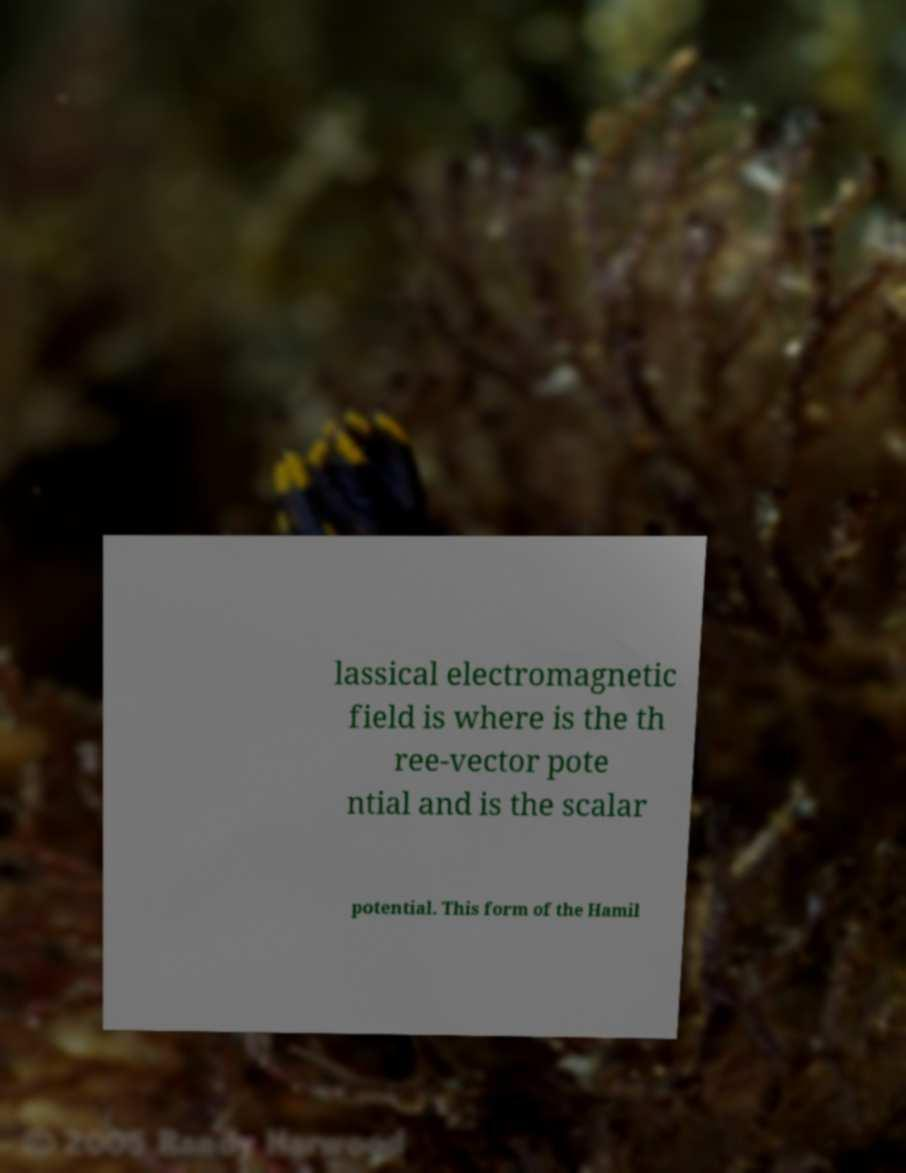Please identify and transcribe the text found in this image. lassical electromagnetic field is where is the th ree-vector pote ntial and is the scalar potential. This form of the Hamil 